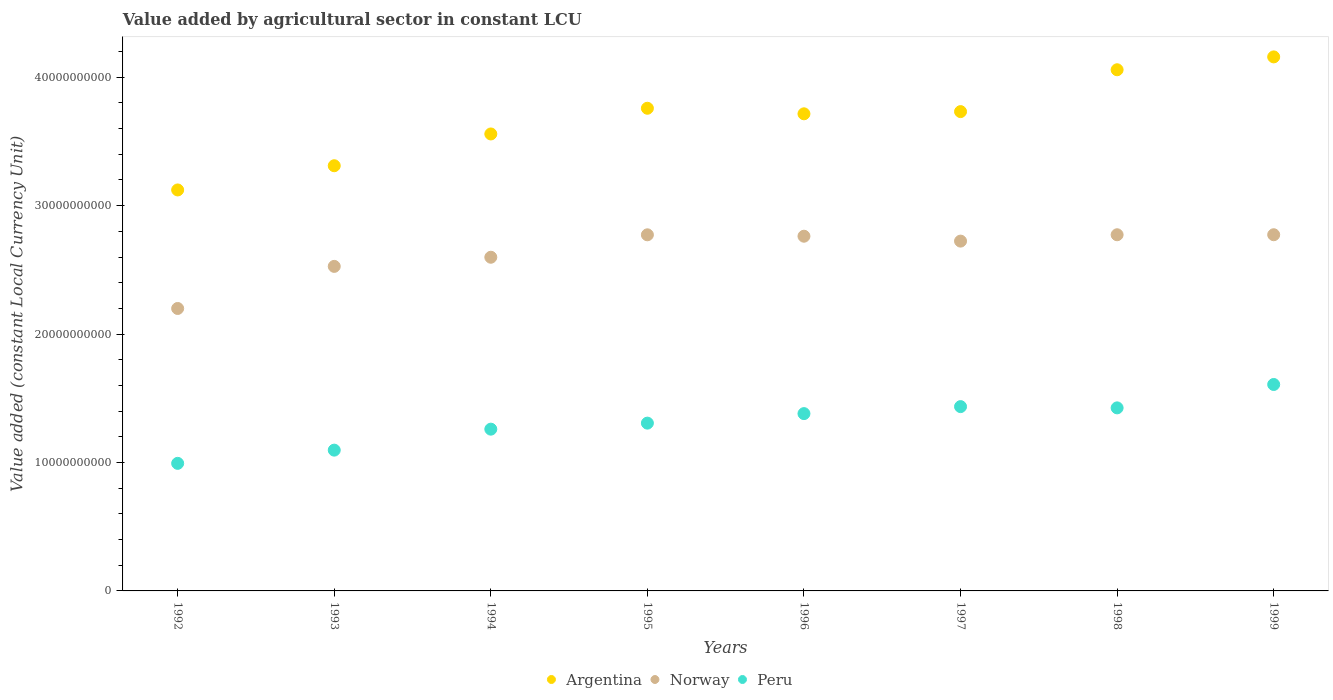How many different coloured dotlines are there?
Provide a short and direct response. 3. What is the value added by agricultural sector in Peru in 1999?
Offer a terse response. 1.61e+1. Across all years, what is the maximum value added by agricultural sector in Peru?
Your answer should be compact. 1.61e+1. Across all years, what is the minimum value added by agricultural sector in Norway?
Offer a terse response. 2.20e+1. What is the total value added by agricultural sector in Argentina in the graph?
Provide a short and direct response. 2.94e+11. What is the difference between the value added by agricultural sector in Peru in 1995 and that in 1999?
Offer a very short reply. -3.01e+09. What is the difference between the value added by agricultural sector in Argentina in 1995 and the value added by agricultural sector in Norway in 1996?
Provide a short and direct response. 9.96e+09. What is the average value added by agricultural sector in Norway per year?
Your answer should be very brief. 2.64e+1. In the year 1997, what is the difference between the value added by agricultural sector in Peru and value added by agricultural sector in Argentina?
Offer a very short reply. -2.30e+1. In how many years, is the value added by agricultural sector in Norway greater than 16000000000 LCU?
Give a very brief answer. 8. What is the ratio of the value added by agricultural sector in Norway in 1997 to that in 1999?
Provide a short and direct response. 0.98. Is the value added by agricultural sector in Norway in 1992 less than that in 1993?
Make the answer very short. Yes. What is the difference between the highest and the second highest value added by agricultural sector in Argentina?
Offer a very short reply. 1.00e+09. What is the difference between the highest and the lowest value added by agricultural sector in Norway?
Offer a very short reply. 5.74e+09. In how many years, is the value added by agricultural sector in Argentina greater than the average value added by agricultural sector in Argentina taken over all years?
Provide a succinct answer. 5. Does the value added by agricultural sector in Argentina monotonically increase over the years?
Offer a terse response. No. Is the value added by agricultural sector in Argentina strictly greater than the value added by agricultural sector in Norway over the years?
Give a very brief answer. Yes. How many years are there in the graph?
Provide a short and direct response. 8. Are the values on the major ticks of Y-axis written in scientific E-notation?
Offer a very short reply. No. Does the graph contain grids?
Ensure brevity in your answer.  No. How are the legend labels stacked?
Offer a very short reply. Horizontal. What is the title of the graph?
Your answer should be very brief. Value added by agricultural sector in constant LCU. What is the label or title of the Y-axis?
Ensure brevity in your answer.  Value added (constant Local Currency Unit). What is the Value added (constant Local Currency Unit) of Argentina in 1992?
Offer a terse response. 3.12e+1. What is the Value added (constant Local Currency Unit) in Norway in 1992?
Offer a very short reply. 2.20e+1. What is the Value added (constant Local Currency Unit) of Peru in 1992?
Offer a very short reply. 9.93e+09. What is the Value added (constant Local Currency Unit) of Argentina in 1993?
Your answer should be compact. 3.31e+1. What is the Value added (constant Local Currency Unit) of Norway in 1993?
Your answer should be very brief. 2.53e+1. What is the Value added (constant Local Currency Unit) in Peru in 1993?
Your response must be concise. 1.10e+1. What is the Value added (constant Local Currency Unit) of Argentina in 1994?
Your answer should be very brief. 3.56e+1. What is the Value added (constant Local Currency Unit) of Norway in 1994?
Keep it short and to the point. 2.60e+1. What is the Value added (constant Local Currency Unit) in Peru in 1994?
Make the answer very short. 1.26e+1. What is the Value added (constant Local Currency Unit) of Argentina in 1995?
Offer a terse response. 3.76e+1. What is the Value added (constant Local Currency Unit) in Norway in 1995?
Give a very brief answer. 2.77e+1. What is the Value added (constant Local Currency Unit) in Peru in 1995?
Your answer should be compact. 1.31e+1. What is the Value added (constant Local Currency Unit) in Argentina in 1996?
Give a very brief answer. 3.72e+1. What is the Value added (constant Local Currency Unit) of Norway in 1996?
Your answer should be very brief. 2.76e+1. What is the Value added (constant Local Currency Unit) in Peru in 1996?
Ensure brevity in your answer.  1.38e+1. What is the Value added (constant Local Currency Unit) of Argentina in 1997?
Ensure brevity in your answer.  3.73e+1. What is the Value added (constant Local Currency Unit) in Norway in 1997?
Make the answer very short. 2.72e+1. What is the Value added (constant Local Currency Unit) of Peru in 1997?
Make the answer very short. 1.44e+1. What is the Value added (constant Local Currency Unit) in Argentina in 1998?
Offer a very short reply. 4.06e+1. What is the Value added (constant Local Currency Unit) of Norway in 1998?
Ensure brevity in your answer.  2.77e+1. What is the Value added (constant Local Currency Unit) of Peru in 1998?
Your answer should be compact. 1.43e+1. What is the Value added (constant Local Currency Unit) in Argentina in 1999?
Keep it short and to the point. 4.16e+1. What is the Value added (constant Local Currency Unit) in Norway in 1999?
Offer a terse response. 2.77e+1. What is the Value added (constant Local Currency Unit) of Peru in 1999?
Ensure brevity in your answer.  1.61e+1. Across all years, what is the maximum Value added (constant Local Currency Unit) in Argentina?
Your response must be concise. 4.16e+1. Across all years, what is the maximum Value added (constant Local Currency Unit) in Norway?
Offer a terse response. 2.77e+1. Across all years, what is the maximum Value added (constant Local Currency Unit) of Peru?
Offer a very short reply. 1.61e+1. Across all years, what is the minimum Value added (constant Local Currency Unit) in Argentina?
Offer a very short reply. 3.12e+1. Across all years, what is the minimum Value added (constant Local Currency Unit) in Norway?
Your response must be concise. 2.20e+1. Across all years, what is the minimum Value added (constant Local Currency Unit) in Peru?
Give a very brief answer. 9.93e+09. What is the total Value added (constant Local Currency Unit) in Argentina in the graph?
Ensure brevity in your answer.  2.94e+11. What is the total Value added (constant Local Currency Unit) in Norway in the graph?
Offer a very short reply. 2.11e+11. What is the total Value added (constant Local Currency Unit) of Peru in the graph?
Offer a very short reply. 1.05e+11. What is the difference between the Value added (constant Local Currency Unit) of Argentina in 1992 and that in 1993?
Provide a short and direct response. -1.89e+09. What is the difference between the Value added (constant Local Currency Unit) in Norway in 1992 and that in 1993?
Your answer should be very brief. -3.28e+09. What is the difference between the Value added (constant Local Currency Unit) in Peru in 1992 and that in 1993?
Make the answer very short. -1.03e+09. What is the difference between the Value added (constant Local Currency Unit) of Argentina in 1992 and that in 1994?
Your response must be concise. -4.36e+09. What is the difference between the Value added (constant Local Currency Unit) of Norway in 1992 and that in 1994?
Provide a succinct answer. -3.99e+09. What is the difference between the Value added (constant Local Currency Unit) of Peru in 1992 and that in 1994?
Offer a terse response. -2.66e+09. What is the difference between the Value added (constant Local Currency Unit) in Argentina in 1992 and that in 1995?
Offer a terse response. -6.36e+09. What is the difference between the Value added (constant Local Currency Unit) in Norway in 1992 and that in 1995?
Provide a short and direct response. -5.74e+09. What is the difference between the Value added (constant Local Currency Unit) in Peru in 1992 and that in 1995?
Keep it short and to the point. -3.13e+09. What is the difference between the Value added (constant Local Currency Unit) in Argentina in 1992 and that in 1996?
Your answer should be very brief. -5.93e+09. What is the difference between the Value added (constant Local Currency Unit) of Norway in 1992 and that in 1996?
Offer a very short reply. -5.63e+09. What is the difference between the Value added (constant Local Currency Unit) in Peru in 1992 and that in 1996?
Provide a short and direct response. -3.87e+09. What is the difference between the Value added (constant Local Currency Unit) in Argentina in 1992 and that in 1997?
Provide a succinct answer. -6.10e+09. What is the difference between the Value added (constant Local Currency Unit) in Norway in 1992 and that in 1997?
Your answer should be very brief. -5.25e+09. What is the difference between the Value added (constant Local Currency Unit) of Peru in 1992 and that in 1997?
Offer a terse response. -4.42e+09. What is the difference between the Value added (constant Local Currency Unit) of Argentina in 1992 and that in 1998?
Provide a succinct answer. -9.36e+09. What is the difference between the Value added (constant Local Currency Unit) of Norway in 1992 and that in 1998?
Your answer should be compact. -5.74e+09. What is the difference between the Value added (constant Local Currency Unit) in Peru in 1992 and that in 1998?
Ensure brevity in your answer.  -4.32e+09. What is the difference between the Value added (constant Local Currency Unit) of Argentina in 1992 and that in 1999?
Your answer should be very brief. -1.04e+1. What is the difference between the Value added (constant Local Currency Unit) of Norway in 1992 and that in 1999?
Make the answer very short. -5.74e+09. What is the difference between the Value added (constant Local Currency Unit) of Peru in 1992 and that in 1999?
Provide a short and direct response. -6.14e+09. What is the difference between the Value added (constant Local Currency Unit) of Argentina in 1993 and that in 1994?
Your answer should be compact. -2.47e+09. What is the difference between the Value added (constant Local Currency Unit) in Norway in 1993 and that in 1994?
Ensure brevity in your answer.  -7.12e+08. What is the difference between the Value added (constant Local Currency Unit) of Peru in 1993 and that in 1994?
Your response must be concise. -1.63e+09. What is the difference between the Value added (constant Local Currency Unit) of Argentina in 1993 and that in 1995?
Your answer should be very brief. -4.48e+09. What is the difference between the Value added (constant Local Currency Unit) of Norway in 1993 and that in 1995?
Keep it short and to the point. -2.46e+09. What is the difference between the Value added (constant Local Currency Unit) in Peru in 1993 and that in 1995?
Offer a terse response. -2.10e+09. What is the difference between the Value added (constant Local Currency Unit) in Argentina in 1993 and that in 1996?
Offer a terse response. -4.04e+09. What is the difference between the Value added (constant Local Currency Unit) in Norway in 1993 and that in 1996?
Make the answer very short. -2.35e+09. What is the difference between the Value added (constant Local Currency Unit) in Peru in 1993 and that in 1996?
Provide a succinct answer. -2.84e+09. What is the difference between the Value added (constant Local Currency Unit) of Argentina in 1993 and that in 1997?
Offer a terse response. -4.21e+09. What is the difference between the Value added (constant Local Currency Unit) of Norway in 1993 and that in 1997?
Offer a terse response. -1.97e+09. What is the difference between the Value added (constant Local Currency Unit) of Peru in 1993 and that in 1997?
Ensure brevity in your answer.  -3.39e+09. What is the difference between the Value added (constant Local Currency Unit) of Argentina in 1993 and that in 1998?
Your answer should be very brief. -7.47e+09. What is the difference between the Value added (constant Local Currency Unit) in Norway in 1993 and that in 1998?
Offer a very short reply. -2.46e+09. What is the difference between the Value added (constant Local Currency Unit) in Peru in 1993 and that in 1998?
Offer a very short reply. -3.29e+09. What is the difference between the Value added (constant Local Currency Unit) in Argentina in 1993 and that in 1999?
Provide a succinct answer. -8.47e+09. What is the difference between the Value added (constant Local Currency Unit) in Norway in 1993 and that in 1999?
Provide a short and direct response. -2.46e+09. What is the difference between the Value added (constant Local Currency Unit) in Peru in 1993 and that in 1999?
Give a very brief answer. -5.11e+09. What is the difference between the Value added (constant Local Currency Unit) in Argentina in 1994 and that in 1995?
Offer a very short reply. -2.00e+09. What is the difference between the Value added (constant Local Currency Unit) of Norway in 1994 and that in 1995?
Provide a succinct answer. -1.75e+09. What is the difference between the Value added (constant Local Currency Unit) of Peru in 1994 and that in 1995?
Keep it short and to the point. -4.69e+08. What is the difference between the Value added (constant Local Currency Unit) of Argentina in 1994 and that in 1996?
Offer a terse response. -1.57e+09. What is the difference between the Value added (constant Local Currency Unit) in Norway in 1994 and that in 1996?
Your answer should be compact. -1.64e+09. What is the difference between the Value added (constant Local Currency Unit) in Peru in 1994 and that in 1996?
Offer a terse response. -1.21e+09. What is the difference between the Value added (constant Local Currency Unit) of Argentina in 1994 and that in 1997?
Your answer should be compact. -1.74e+09. What is the difference between the Value added (constant Local Currency Unit) in Norway in 1994 and that in 1997?
Your response must be concise. -1.26e+09. What is the difference between the Value added (constant Local Currency Unit) in Peru in 1994 and that in 1997?
Your answer should be compact. -1.76e+09. What is the difference between the Value added (constant Local Currency Unit) in Argentina in 1994 and that in 1998?
Offer a terse response. -5.00e+09. What is the difference between the Value added (constant Local Currency Unit) of Norway in 1994 and that in 1998?
Provide a succinct answer. -1.75e+09. What is the difference between the Value added (constant Local Currency Unit) in Peru in 1994 and that in 1998?
Ensure brevity in your answer.  -1.66e+09. What is the difference between the Value added (constant Local Currency Unit) of Argentina in 1994 and that in 1999?
Give a very brief answer. -6.00e+09. What is the difference between the Value added (constant Local Currency Unit) of Norway in 1994 and that in 1999?
Make the answer very short. -1.75e+09. What is the difference between the Value added (constant Local Currency Unit) of Peru in 1994 and that in 1999?
Your response must be concise. -3.48e+09. What is the difference between the Value added (constant Local Currency Unit) in Argentina in 1995 and that in 1996?
Offer a terse response. 4.32e+08. What is the difference between the Value added (constant Local Currency Unit) of Norway in 1995 and that in 1996?
Your answer should be very brief. 1.09e+08. What is the difference between the Value added (constant Local Currency Unit) in Peru in 1995 and that in 1996?
Provide a short and direct response. -7.41e+08. What is the difference between the Value added (constant Local Currency Unit) in Argentina in 1995 and that in 1997?
Your answer should be very brief. 2.61e+08. What is the difference between the Value added (constant Local Currency Unit) of Norway in 1995 and that in 1997?
Your answer should be very brief. 4.91e+08. What is the difference between the Value added (constant Local Currency Unit) in Peru in 1995 and that in 1997?
Provide a short and direct response. -1.29e+09. What is the difference between the Value added (constant Local Currency Unit) in Argentina in 1995 and that in 1998?
Provide a short and direct response. -3.00e+09. What is the difference between the Value added (constant Local Currency Unit) in Norway in 1995 and that in 1998?
Provide a succinct answer. -4.58e+06. What is the difference between the Value added (constant Local Currency Unit) in Peru in 1995 and that in 1998?
Offer a terse response. -1.19e+09. What is the difference between the Value added (constant Local Currency Unit) in Argentina in 1995 and that in 1999?
Make the answer very short. -4.00e+09. What is the difference between the Value added (constant Local Currency Unit) of Norway in 1995 and that in 1999?
Provide a succinct answer. -5.73e+06. What is the difference between the Value added (constant Local Currency Unit) of Peru in 1995 and that in 1999?
Your answer should be compact. -3.01e+09. What is the difference between the Value added (constant Local Currency Unit) in Argentina in 1996 and that in 1997?
Give a very brief answer. -1.71e+08. What is the difference between the Value added (constant Local Currency Unit) in Norway in 1996 and that in 1997?
Offer a very short reply. 3.82e+08. What is the difference between the Value added (constant Local Currency Unit) of Peru in 1996 and that in 1997?
Give a very brief answer. -5.45e+08. What is the difference between the Value added (constant Local Currency Unit) of Argentina in 1996 and that in 1998?
Provide a succinct answer. -3.43e+09. What is the difference between the Value added (constant Local Currency Unit) in Norway in 1996 and that in 1998?
Make the answer very short. -1.13e+08. What is the difference between the Value added (constant Local Currency Unit) in Peru in 1996 and that in 1998?
Your response must be concise. -4.47e+08. What is the difference between the Value added (constant Local Currency Unit) of Argentina in 1996 and that in 1999?
Give a very brief answer. -4.43e+09. What is the difference between the Value added (constant Local Currency Unit) of Norway in 1996 and that in 1999?
Offer a terse response. -1.15e+08. What is the difference between the Value added (constant Local Currency Unit) of Peru in 1996 and that in 1999?
Make the answer very short. -2.27e+09. What is the difference between the Value added (constant Local Currency Unit) of Argentina in 1997 and that in 1998?
Keep it short and to the point. -3.26e+09. What is the difference between the Value added (constant Local Currency Unit) in Norway in 1997 and that in 1998?
Your response must be concise. -4.95e+08. What is the difference between the Value added (constant Local Currency Unit) of Peru in 1997 and that in 1998?
Provide a succinct answer. 9.80e+07. What is the difference between the Value added (constant Local Currency Unit) in Argentina in 1997 and that in 1999?
Provide a succinct answer. -4.26e+09. What is the difference between the Value added (constant Local Currency Unit) in Norway in 1997 and that in 1999?
Ensure brevity in your answer.  -4.96e+08. What is the difference between the Value added (constant Local Currency Unit) of Peru in 1997 and that in 1999?
Ensure brevity in your answer.  -1.72e+09. What is the difference between the Value added (constant Local Currency Unit) of Argentina in 1998 and that in 1999?
Your answer should be very brief. -1.00e+09. What is the difference between the Value added (constant Local Currency Unit) of Norway in 1998 and that in 1999?
Keep it short and to the point. -1.15e+06. What is the difference between the Value added (constant Local Currency Unit) of Peru in 1998 and that in 1999?
Your answer should be very brief. -1.82e+09. What is the difference between the Value added (constant Local Currency Unit) of Argentina in 1992 and the Value added (constant Local Currency Unit) of Norway in 1993?
Give a very brief answer. 5.95e+09. What is the difference between the Value added (constant Local Currency Unit) of Argentina in 1992 and the Value added (constant Local Currency Unit) of Peru in 1993?
Offer a terse response. 2.03e+1. What is the difference between the Value added (constant Local Currency Unit) of Norway in 1992 and the Value added (constant Local Currency Unit) of Peru in 1993?
Offer a very short reply. 1.10e+1. What is the difference between the Value added (constant Local Currency Unit) in Argentina in 1992 and the Value added (constant Local Currency Unit) in Norway in 1994?
Keep it short and to the point. 5.24e+09. What is the difference between the Value added (constant Local Currency Unit) in Argentina in 1992 and the Value added (constant Local Currency Unit) in Peru in 1994?
Provide a succinct answer. 1.86e+1. What is the difference between the Value added (constant Local Currency Unit) of Norway in 1992 and the Value added (constant Local Currency Unit) of Peru in 1994?
Give a very brief answer. 9.40e+09. What is the difference between the Value added (constant Local Currency Unit) of Argentina in 1992 and the Value added (constant Local Currency Unit) of Norway in 1995?
Offer a terse response. 3.49e+09. What is the difference between the Value added (constant Local Currency Unit) of Argentina in 1992 and the Value added (constant Local Currency Unit) of Peru in 1995?
Your answer should be compact. 1.82e+1. What is the difference between the Value added (constant Local Currency Unit) of Norway in 1992 and the Value added (constant Local Currency Unit) of Peru in 1995?
Give a very brief answer. 8.93e+09. What is the difference between the Value added (constant Local Currency Unit) of Argentina in 1992 and the Value added (constant Local Currency Unit) of Norway in 1996?
Offer a terse response. 3.60e+09. What is the difference between the Value added (constant Local Currency Unit) in Argentina in 1992 and the Value added (constant Local Currency Unit) in Peru in 1996?
Ensure brevity in your answer.  1.74e+1. What is the difference between the Value added (constant Local Currency Unit) in Norway in 1992 and the Value added (constant Local Currency Unit) in Peru in 1996?
Give a very brief answer. 8.19e+09. What is the difference between the Value added (constant Local Currency Unit) of Argentina in 1992 and the Value added (constant Local Currency Unit) of Norway in 1997?
Your answer should be very brief. 3.98e+09. What is the difference between the Value added (constant Local Currency Unit) in Argentina in 1992 and the Value added (constant Local Currency Unit) in Peru in 1997?
Give a very brief answer. 1.69e+1. What is the difference between the Value added (constant Local Currency Unit) in Norway in 1992 and the Value added (constant Local Currency Unit) in Peru in 1997?
Your response must be concise. 7.64e+09. What is the difference between the Value added (constant Local Currency Unit) of Argentina in 1992 and the Value added (constant Local Currency Unit) of Norway in 1998?
Offer a very short reply. 3.49e+09. What is the difference between the Value added (constant Local Currency Unit) of Argentina in 1992 and the Value added (constant Local Currency Unit) of Peru in 1998?
Your answer should be compact. 1.70e+1. What is the difference between the Value added (constant Local Currency Unit) in Norway in 1992 and the Value added (constant Local Currency Unit) in Peru in 1998?
Provide a succinct answer. 7.74e+09. What is the difference between the Value added (constant Local Currency Unit) of Argentina in 1992 and the Value added (constant Local Currency Unit) of Norway in 1999?
Offer a very short reply. 3.49e+09. What is the difference between the Value added (constant Local Currency Unit) in Argentina in 1992 and the Value added (constant Local Currency Unit) in Peru in 1999?
Give a very brief answer. 1.51e+1. What is the difference between the Value added (constant Local Currency Unit) of Norway in 1992 and the Value added (constant Local Currency Unit) of Peru in 1999?
Keep it short and to the point. 5.92e+09. What is the difference between the Value added (constant Local Currency Unit) in Argentina in 1993 and the Value added (constant Local Currency Unit) in Norway in 1994?
Your answer should be very brief. 7.13e+09. What is the difference between the Value added (constant Local Currency Unit) of Argentina in 1993 and the Value added (constant Local Currency Unit) of Peru in 1994?
Provide a succinct answer. 2.05e+1. What is the difference between the Value added (constant Local Currency Unit) in Norway in 1993 and the Value added (constant Local Currency Unit) in Peru in 1994?
Your answer should be very brief. 1.27e+1. What is the difference between the Value added (constant Local Currency Unit) in Argentina in 1993 and the Value added (constant Local Currency Unit) in Norway in 1995?
Give a very brief answer. 5.38e+09. What is the difference between the Value added (constant Local Currency Unit) of Argentina in 1993 and the Value added (constant Local Currency Unit) of Peru in 1995?
Make the answer very short. 2.00e+1. What is the difference between the Value added (constant Local Currency Unit) of Norway in 1993 and the Value added (constant Local Currency Unit) of Peru in 1995?
Ensure brevity in your answer.  1.22e+1. What is the difference between the Value added (constant Local Currency Unit) of Argentina in 1993 and the Value added (constant Local Currency Unit) of Norway in 1996?
Make the answer very short. 5.49e+09. What is the difference between the Value added (constant Local Currency Unit) in Argentina in 1993 and the Value added (constant Local Currency Unit) in Peru in 1996?
Keep it short and to the point. 1.93e+1. What is the difference between the Value added (constant Local Currency Unit) of Norway in 1993 and the Value added (constant Local Currency Unit) of Peru in 1996?
Offer a terse response. 1.15e+1. What is the difference between the Value added (constant Local Currency Unit) in Argentina in 1993 and the Value added (constant Local Currency Unit) in Norway in 1997?
Offer a terse response. 5.87e+09. What is the difference between the Value added (constant Local Currency Unit) of Argentina in 1993 and the Value added (constant Local Currency Unit) of Peru in 1997?
Make the answer very short. 1.88e+1. What is the difference between the Value added (constant Local Currency Unit) of Norway in 1993 and the Value added (constant Local Currency Unit) of Peru in 1997?
Your response must be concise. 1.09e+1. What is the difference between the Value added (constant Local Currency Unit) in Argentina in 1993 and the Value added (constant Local Currency Unit) in Norway in 1998?
Provide a succinct answer. 5.37e+09. What is the difference between the Value added (constant Local Currency Unit) of Argentina in 1993 and the Value added (constant Local Currency Unit) of Peru in 1998?
Offer a terse response. 1.89e+1. What is the difference between the Value added (constant Local Currency Unit) in Norway in 1993 and the Value added (constant Local Currency Unit) in Peru in 1998?
Ensure brevity in your answer.  1.10e+1. What is the difference between the Value added (constant Local Currency Unit) of Argentina in 1993 and the Value added (constant Local Currency Unit) of Norway in 1999?
Offer a very short reply. 5.37e+09. What is the difference between the Value added (constant Local Currency Unit) in Argentina in 1993 and the Value added (constant Local Currency Unit) in Peru in 1999?
Ensure brevity in your answer.  1.70e+1. What is the difference between the Value added (constant Local Currency Unit) of Norway in 1993 and the Value added (constant Local Currency Unit) of Peru in 1999?
Give a very brief answer. 9.20e+09. What is the difference between the Value added (constant Local Currency Unit) of Argentina in 1994 and the Value added (constant Local Currency Unit) of Norway in 1995?
Offer a very short reply. 7.85e+09. What is the difference between the Value added (constant Local Currency Unit) of Argentina in 1994 and the Value added (constant Local Currency Unit) of Peru in 1995?
Your response must be concise. 2.25e+1. What is the difference between the Value added (constant Local Currency Unit) in Norway in 1994 and the Value added (constant Local Currency Unit) in Peru in 1995?
Give a very brief answer. 1.29e+1. What is the difference between the Value added (constant Local Currency Unit) in Argentina in 1994 and the Value added (constant Local Currency Unit) in Norway in 1996?
Make the answer very short. 7.96e+09. What is the difference between the Value added (constant Local Currency Unit) of Argentina in 1994 and the Value added (constant Local Currency Unit) of Peru in 1996?
Provide a succinct answer. 2.18e+1. What is the difference between the Value added (constant Local Currency Unit) in Norway in 1994 and the Value added (constant Local Currency Unit) in Peru in 1996?
Provide a short and direct response. 1.22e+1. What is the difference between the Value added (constant Local Currency Unit) in Argentina in 1994 and the Value added (constant Local Currency Unit) in Norway in 1997?
Your answer should be very brief. 8.34e+09. What is the difference between the Value added (constant Local Currency Unit) in Argentina in 1994 and the Value added (constant Local Currency Unit) in Peru in 1997?
Keep it short and to the point. 2.12e+1. What is the difference between the Value added (constant Local Currency Unit) of Norway in 1994 and the Value added (constant Local Currency Unit) of Peru in 1997?
Your answer should be compact. 1.16e+1. What is the difference between the Value added (constant Local Currency Unit) of Argentina in 1994 and the Value added (constant Local Currency Unit) of Norway in 1998?
Your answer should be very brief. 7.85e+09. What is the difference between the Value added (constant Local Currency Unit) of Argentina in 1994 and the Value added (constant Local Currency Unit) of Peru in 1998?
Ensure brevity in your answer.  2.13e+1. What is the difference between the Value added (constant Local Currency Unit) of Norway in 1994 and the Value added (constant Local Currency Unit) of Peru in 1998?
Make the answer very short. 1.17e+1. What is the difference between the Value added (constant Local Currency Unit) in Argentina in 1994 and the Value added (constant Local Currency Unit) in Norway in 1999?
Your answer should be compact. 7.85e+09. What is the difference between the Value added (constant Local Currency Unit) of Argentina in 1994 and the Value added (constant Local Currency Unit) of Peru in 1999?
Provide a short and direct response. 1.95e+1. What is the difference between the Value added (constant Local Currency Unit) in Norway in 1994 and the Value added (constant Local Currency Unit) in Peru in 1999?
Your answer should be compact. 9.91e+09. What is the difference between the Value added (constant Local Currency Unit) of Argentina in 1995 and the Value added (constant Local Currency Unit) of Norway in 1996?
Your answer should be very brief. 9.96e+09. What is the difference between the Value added (constant Local Currency Unit) of Argentina in 1995 and the Value added (constant Local Currency Unit) of Peru in 1996?
Your answer should be very brief. 2.38e+1. What is the difference between the Value added (constant Local Currency Unit) in Norway in 1995 and the Value added (constant Local Currency Unit) in Peru in 1996?
Provide a short and direct response. 1.39e+1. What is the difference between the Value added (constant Local Currency Unit) of Argentina in 1995 and the Value added (constant Local Currency Unit) of Norway in 1997?
Your answer should be very brief. 1.03e+1. What is the difference between the Value added (constant Local Currency Unit) in Argentina in 1995 and the Value added (constant Local Currency Unit) in Peru in 1997?
Your answer should be very brief. 2.32e+1. What is the difference between the Value added (constant Local Currency Unit) of Norway in 1995 and the Value added (constant Local Currency Unit) of Peru in 1997?
Offer a very short reply. 1.34e+1. What is the difference between the Value added (constant Local Currency Unit) of Argentina in 1995 and the Value added (constant Local Currency Unit) of Norway in 1998?
Your response must be concise. 9.85e+09. What is the difference between the Value added (constant Local Currency Unit) of Argentina in 1995 and the Value added (constant Local Currency Unit) of Peru in 1998?
Your answer should be compact. 2.33e+1. What is the difference between the Value added (constant Local Currency Unit) in Norway in 1995 and the Value added (constant Local Currency Unit) in Peru in 1998?
Ensure brevity in your answer.  1.35e+1. What is the difference between the Value added (constant Local Currency Unit) of Argentina in 1995 and the Value added (constant Local Currency Unit) of Norway in 1999?
Your answer should be compact. 9.85e+09. What is the difference between the Value added (constant Local Currency Unit) in Argentina in 1995 and the Value added (constant Local Currency Unit) in Peru in 1999?
Provide a short and direct response. 2.15e+1. What is the difference between the Value added (constant Local Currency Unit) of Norway in 1995 and the Value added (constant Local Currency Unit) of Peru in 1999?
Provide a short and direct response. 1.17e+1. What is the difference between the Value added (constant Local Currency Unit) of Argentina in 1996 and the Value added (constant Local Currency Unit) of Norway in 1997?
Make the answer very short. 9.91e+09. What is the difference between the Value added (constant Local Currency Unit) of Argentina in 1996 and the Value added (constant Local Currency Unit) of Peru in 1997?
Your answer should be compact. 2.28e+1. What is the difference between the Value added (constant Local Currency Unit) of Norway in 1996 and the Value added (constant Local Currency Unit) of Peru in 1997?
Provide a succinct answer. 1.33e+1. What is the difference between the Value added (constant Local Currency Unit) in Argentina in 1996 and the Value added (constant Local Currency Unit) in Norway in 1998?
Your answer should be very brief. 9.42e+09. What is the difference between the Value added (constant Local Currency Unit) of Argentina in 1996 and the Value added (constant Local Currency Unit) of Peru in 1998?
Keep it short and to the point. 2.29e+1. What is the difference between the Value added (constant Local Currency Unit) of Norway in 1996 and the Value added (constant Local Currency Unit) of Peru in 1998?
Your answer should be compact. 1.34e+1. What is the difference between the Value added (constant Local Currency Unit) of Argentina in 1996 and the Value added (constant Local Currency Unit) of Norway in 1999?
Offer a terse response. 9.42e+09. What is the difference between the Value added (constant Local Currency Unit) in Argentina in 1996 and the Value added (constant Local Currency Unit) in Peru in 1999?
Your response must be concise. 2.11e+1. What is the difference between the Value added (constant Local Currency Unit) of Norway in 1996 and the Value added (constant Local Currency Unit) of Peru in 1999?
Offer a terse response. 1.15e+1. What is the difference between the Value added (constant Local Currency Unit) in Argentina in 1997 and the Value added (constant Local Currency Unit) in Norway in 1998?
Your answer should be very brief. 9.59e+09. What is the difference between the Value added (constant Local Currency Unit) of Argentina in 1997 and the Value added (constant Local Currency Unit) of Peru in 1998?
Provide a short and direct response. 2.31e+1. What is the difference between the Value added (constant Local Currency Unit) of Norway in 1997 and the Value added (constant Local Currency Unit) of Peru in 1998?
Provide a short and direct response. 1.30e+1. What is the difference between the Value added (constant Local Currency Unit) in Argentina in 1997 and the Value added (constant Local Currency Unit) in Norway in 1999?
Your answer should be very brief. 9.59e+09. What is the difference between the Value added (constant Local Currency Unit) of Argentina in 1997 and the Value added (constant Local Currency Unit) of Peru in 1999?
Keep it short and to the point. 2.12e+1. What is the difference between the Value added (constant Local Currency Unit) of Norway in 1997 and the Value added (constant Local Currency Unit) of Peru in 1999?
Offer a very short reply. 1.12e+1. What is the difference between the Value added (constant Local Currency Unit) in Argentina in 1998 and the Value added (constant Local Currency Unit) in Norway in 1999?
Your response must be concise. 1.28e+1. What is the difference between the Value added (constant Local Currency Unit) in Argentina in 1998 and the Value added (constant Local Currency Unit) in Peru in 1999?
Ensure brevity in your answer.  2.45e+1. What is the difference between the Value added (constant Local Currency Unit) of Norway in 1998 and the Value added (constant Local Currency Unit) of Peru in 1999?
Ensure brevity in your answer.  1.17e+1. What is the average Value added (constant Local Currency Unit) of Argentina per year?
Provide a succinct answer. 3.68e+1. What is the average Value added (constant Local Currency Unit) in Norway per year?
Ensure brevity in your answer.  2.64e+1. What is the average Value added (constant Local Currency Unit) in Peru per year?
Your response must be concise. 1.31e+1. In the year 1992, what is the difference between the Value added (constant Local Currency Unit) in Argentina and Value added (constant Local Currency Unit) in Norway?
Your response must be concise. 9.23e+09. In the year 1992, what is the difference between the Value added (constant Local Currency Unit) of Argentina and Value added (constant Local Currency Unit) of Peru?
Your answer should be very brief. 2.13e+1. In the year 1992, what is the difference between the Value added (constant Local Currency Unit) of Norway and Value added (constant Local Currency Unit) of Peru?
Offer a very short reply. 1.21e+1. In the year 1993, what is the difference between the Value added (constant Local Currency Unit) of Argentina and Value added (constant Local Currency Unit) of Norway?
Your response must be concise. 7.84e+09. In the year 1993, what is the difference between the Value added (constant Local Currency Unit) of Argentina and Value added (constant Local Currency Unit) of Peru?
Give a very brief answer. 2.21e+1. In the year 1993, what is the difference between the Value added (constant Local Currency Unit) of Norway and Value added (constant Local Currency Unit) of Peru?
Your response must be concise. 1.43e+1. In the year 1994, what is the difference between the Value added (constant Local Currency Unit) of Argentina and Value added (constant Local Currency Unit) of Norway?
Ensure brevity in your answer.  9.60e+09. In the year 1994, what is the difference between the Value added (constant Local Currency Unit) in Argentina and Value added (constant Local Currency Unit) in Peru?
Give a very brief answer. 2.30e+1. In the year 1994, what is the difference between the Value added (constant Local Currency Unit) of Norway and Value added (constant Local Currency Unit) of Peru?
Provide a succinct answer. 1.34e+1. In the year 1995, what is the difference between the Value added (constant Local Currency Unit) in Argentina and Value added (constant Local Currency Unit) in Norway?
Your answer should be very brief. 9.85e+09. In the year 1995, what is the difference between the Value added (constant Local Currency Unit) in Argentina and Value added (constant Local Currency Unit) in Peru?
Provide a short and direct response. 2.45e+1. In the year 1995, what is the difference between the Value added (constant Local Currency Unit) of Norway and Value added (constant Local Currency Unit) of Peru?
Make the answer very short. 1.47e+1. In the year 1996, what is the difference between the Value added (constant Local Currency Unit) in Argentina and Value added (constant Local Currency Unit) in Norway?
Give a very brief answer. 9.53e+09. In the year 1996, what is the difference between the Value added (constant Local Currency Unit) of Argentina and Value added (constant Local Currency Unit) of Peru?
Give a very brief answer. 2.33e+1. In the year 1996, what is the difference between the Value added (constant Local Currency Unit) in Norway and Value added (constant Local Currency Unit) in Peru?
Provide a short and direct response. 1.38e+1. In the year 1997, what is the difference between the Value added (constant Local Currency Unit) in Argentina and Value added (constant Local Currency Unit) in Norway?
Your response must be concise. 1.01e+1. In the year 1997, what is the difference between the Value added (constant Local Currency Unit) in Argentina and Value added (constant Local Currency Unit) in Peru?
Ensure brevity in your answer.  2.30e+1. In the year 1997, what is the difference between the Value added (constant Local Currency Unit) in Norway and Value added (constant Local Currency Unit) in Peru?
Make the answer very short. 1.29e+1. In the year 1998, what is the difference between the Value added (constant Local Currency Unit) of Argentina and Value added (constant Local Currency Unit) of Norway?
Your response must be concise. 1.28e+1. In the year 1998, what is the difference between the Value added (constant Local Currency Unit) in Argentina and Value added (constant Local Currency Unit) in Peru?
Provide a succinct answer. 2.63e+1. In the year 1998, what is the difference between the Value added (constant Local Currency Unit) of Norway and Value added (constant Local Currency Unit) of Peru?
Make the answer very short. 1.35e+1. In the year 1999, what is the difference between the Value added (constant Local Currency Unit) of Argentina and Value added (constant Local Currency Unit) of Norway?
Keep it short and to the point. 1.38e+1. In the year 1999, what is the difference between the Value added (constant Local Currency Unit) in Argentina and Value added (constant Local Currency Unit) in Peru?
Offer a very short reply. 2.55e+1. In the year 1999, what is the difference between the Value added (constant Local Currency Unit) in Norway and Value added (constant Local Currency Unit) in Peru?
Your answer should be very brief. 1.17e+1. What is the ratio of the Value added (constant Local Currency Unit) in Argentina in 1992 to that in 1993?
Provide a short and direct response. 0.94. What is the ratio of the Value added (constant Local Currency Unit) in Norway in 1992 to that in 1993?
Make the answer very short. 0.87. What is the ratio of the Value added (constant Local Currency Unit) in Peru in 1992 to that in 1993?
Your answer should be compact. 0.91. What is the ratio of the Value added (constant Local Currency Unit) in Argentina in 1992 to that in 1994?
Offer a very short reply. 0.88. What is the ratio of the Value added (constant Local Currency Unit) in Norway in 1992 to that in 1994?
Offer a terse response. 0.85. What is the ratio of the Value added (constant Local Currency Unit) of Peru in 1992 to that in 1994?
Provide a short and direct response. 0.79. What is the ratio of the Value added (constant Local Currency Unit) in Argentina in 1992 to that in 1995?
Keep it short and to the point. 0.83. What is the ratio of the Value added (constant Local Currency Unit) of Norway in 1992 to that in 1995?
Ensure brevity in your answer.  0.79. What is the ratio of the Value added (constant Local Currency Unit) of Peru in 1992 to that in 1995?
Keep it short and to the point. 0.76. What is the ratio of the Value added (constant Local Currency Unit) of Argentina in 1992 to that in 1996?
Your answer should be compact. 0.84. What is the ratio of the Value added (constant Local Currency Unit) in Norway in 1992 to that in 1996?
Offer a very short reply. 0.8. What is the ratio of the Value added (constant Local Currency Unit) in Peru in 1992 to that in 1996?
Your answer should be very brief. 0.72. What is the ratio of the Value added (constant Local Currency Unit) of Argentina in 1992 to that in 1997?
Provide a succinct answer. 0.84. What is the ratio of the Value added (constant Local Currency Unit) of Norway in 1992 to that in 1997?
Offer a terse response. 0.81. What is the ratio of the Value added (constant Local Currency Unit) in Peru in 1992 to that in 1997?
Your answer should be very brief. 0.69. What is the ratio of the Value added (constant Local Currency Unit) of Argentina in 1992 to that in 1998?
Provide a short and direct response. 0.77. What is the ratio of the Value added (constant Local Currency Unit) in Norway in 1992 to that in 1998?
Your answer should be very brief. 0.79. What is the ratio of the Value added (constant Local Currency Unit) of Peru in 1992 to that in 1998?
Give a very brief answer. 0.7. What is the ratio of the Value added (constant Local Currency Unit) in Argentina in 1992 to that in 1999?
Your answer should be compact. 0.75. What is the ratio of the Value added (constant Local Currency Unit) in Norway in 1992 to that in 1999?
Give a very brief answer. 0.79. What is the ratio of the Value added (constant Local Currency Unit) of Peru in 1992 to that in 1999?
Ensure brevity in your answer.  0.62. What is the ratio of the Value added (constant Local Currency Unit) of Argentina in 1993 to that in 1994?
Your response must be concise. 0.93. What is the ratio of the Value added (constant Local Currency Unit) of Norway in 1993 to that in 1994?
Make the answer very short. 0.97. What is the ratio of the Value added (constant Local Currency Unit) in Peru in 1993 to that in 1994?
Offer a very short reply. 0.87. What is the ratio of the Value added (constant Local Currency Unit) in Argentina in 1993 to that in 1995?
Your response must be concise. 0.88. What is the ratio of the Value added (constant Local Currency Unit) in Norway in 1993 to that in 1995?
Your answer should be compact. 0.91. What is the ratio of the Value added (constant Local Currency Unit) of Peru in 1993 to that in 1995?
Provide a succinct answer. 0.84. What is the ratio of the Value added (constant Local Currency Unit) in Argentina in 1993 to that in 1996?
Give a very brief answer. 0.89. What is the ratio of the Value added (constant Local Currency Unit) of Norway in 1993 to that in 1996?
Provide a succinct answer. 0.91. What is the ratio of the Value added (constant Local Currency Unit) of Peru in 1993 to that in 1996?
Give a very brief answer. 0.79. What is the ratio of the Value added (constant Local Currency Unit) of Argentina in 1993 to that in 1997?
Make the answer very short. 0.89. What is the ratio of the Value added (constant Local Currency Unit) in Norway in 1993 to that in 1997?
Offer a very short reply. 0.93. What is the ratio of the Value added (constant Local Currency Unit) in Peru in 1993 to that in 1997?
Your answer should be compact. 0.76. What is the ratio of the Value added (constant Local Currency Unit) in Argentina in 1993 to that in 1998?
Your answer should be compact. 0.82. What is the ratio of the Value added (constant Local Currency Unit) of Norway in 1993 to that in 1998?
Provide a short and direct response. 0.91. What is the ratio of the Value added (constant Local Currency Unit) in Peru in 1993 to that in 1998?
Offer a very short reply. 0.77. What is the ratio of the Value added (constant Local Currency Unit) in Argentina in 1993 to that in 1999?
Offer a terse response. 0.8. What is the ratio of the Value added (constant Local Currency Unit) in Norway in 1993 to that in 1999?
Offer a terse response. 0.91. What is the ratio of the Value added (constant Local Currency Unit) of Peru in 1993 to that in 1999?
Ensure brevity in your answer.  0.68. What is the ratio of the Value added (constant Local Currency Unit) in Argentina in 1994 to that in 1995?
Your response must be concise. 0.95. What is the ratio of the Value added (constant Local Currency Unit) of Norway in 1994 to that in 1995?
Ensure brevity in your answer.  0.94. What is the ratio of the Value added (constant Local Currency Unit) in Peru in 1994 to that in 1995?
Offer a very short reply. 0.96. What is the ratio of the Value added (constant Local Currency Unit) of Argentina in 1994 to that in 1996?
Give a very brief answer. 0.96. What is the ratio of the Value added (constant Local Currency Unit) in Norway in 1994 to that in 1996?
Provide a succinct answer. 0.94. What is the ratio of the Value added (constant Local Currency Unit) of Peru in 1994 to that in 1996?
Your answer should be compact. 0.91. What is the ratio of the Value added (constant Local Currency Unit) in Argentina in 1994 to that in 1997?
Your answer should be compact. 0.95. What is the ratio of the Value added (constant Local Currency Unit) of Norway in 1994 to that in 1997?
Keep it short and to the point. 0.95. What is the ratio of the Value added (constant Local Currency Unit) of Peru in 1994 to that in 1997?
Make the answer very short. 0.88. What is the ratio of the Value added (constant Local Currency Unit) of Argentina in 1994 to that in 1998?
Keep it short and to the point. 0.88. What is the ratio of the Value added (constant Local Currency Unit) of Norway in 1994 to that in 1998?
Make the answer very short. 0.94. What is the ratio of the Value added (constant Local Currency Unit) in Peru in 1994 to that in 1998?
Offer a terse response. 0.88. What is the ratio of the Value added (constant Local Currency Unit) of Argentina in 1994 to that in 1999?
Offer a terse response. 0.86. What is the ratio of the Value added (constant Local Currency Unit) of Norway in 1994 to that in 1999?
Offer a very short reply. 0.94. What is the ratio of the Value added (constant Local Currency Unit) in Peru in 1994 to that in 1999?
Your answer should be very brief. 0.78. What is the ratio of the Value added (constant Local Currency Unit) in Argentina in 1995 to that in 1996?
Offer a terse response. 1.01. What is the ratio of the Value added (constant Local Currency Unit) of Peru in 1995 to that in 1996?
Your answer should be very brief. 0.95. What is the ratio of the Value added (constant Local Currency Unit) of Peru in 1995 to that in 1997?
Offer a terse response. 0.91. What is the ratio of the Value added (constant Local Currency Unit) in Argentina in 1995 to that in 1998?
Offer a terse response. 0.93. What is the ratio of the Value added (constant Local Currency Unit) of Norway in 1995 to that in 1998?
Your response must be concise. 1. What is the ratio of the Value added (constant Local Currency Unit) of Peru in 1995 to that in 1998?
Your response must be concise. 0.92. What is the ratio of the Value added (constant Local Currency Unit) of Argentina in 1995 to that in 1999?
Your answer should be compact. 0.9. What is the ratio of the Value added (constant Local Currency Unit) of Norway in 1995 to that in 1999?
Make the answer very short. 1. What is the ratio of the Value added (constant Local Currency Unit) in Peru in 1995 to that in 1999?
Your response must be concise. 0.81. What is the ratio of the Value added (constant Local Currency Unit) of Argentina in 1996 to that in 1997?
Your answer should be compact. 1. What is the ratio of the Value added (constant Local Currency Unit) in Norway in 1996 to that in 1997?
Offer a terse response. 1.01. What is the ratio of the Value added (constant Local Currency Unit) in Peru in 1996 to that in 1997?
Provide a short and direct response. 0.96. What is the ratio of the Value added (constant Local Currency Unit) in Argentina in 1996 to that in 1998?
Your response must be concise. 0.92. What is the ratio of the Value added (constant Local Currency Unit) of Norway in 1996 to that in 1998?
Provide a short and direct response. 1. What is the ratio of the Value added (constant Local Currency Unit) in Peru in 1996 to that in 1998?
Make the answer very short. 0.97. What is the ratio of the Value added (constant Local Currency Unit) of Argentina in 1996 to that in 1999?
Keep it short and to the point. 0.89. What is the ratio of the Value added (constant Local Currency Unit) of Peru in 1996 to that in 1999?
Your response must be concise. 0.86. What is the ratio of the Value added (constant Local Currency Unit) in Argentina in 1997 to that in 1998?
Your response must be concise. 0.92. What is the ratio of the Value added (constant Local Currency Unit) in Norway in 1997 to that in 1998?
Ensure brevity in your answer.  0.98. What is the ratio of the Value added (constant Local Currency Unit) in Argentina in 1997 to that in 1999?
Make the answer very short. 0.9. What is the ratio of the Value added (constant Local Currency Unit) in Norway in 1997 to that in 1999?
Your answer should be compact. 0.98. What is the ratio of the Value added (constant Local Currency Unit) in Peru in 1997 to that in 1999?
Ensure brevity in your answer.  0.89. What is the ratio of the Value added (constant Local Currency Unit) in Argentina in 1998 to that in 1999?
Your answer should be compact. 0.98. What is the ratio of the Value added (constant Local Currency Unit) in Norway in 1998 to that in 1999?
Make the answer very short. 1. What is the ratio of the Value added (constant Local Currency Unit) of Peru in 1998 to that in 1999?
Make the answer very short. 0.89. What is the difference between the highest and the second highest Value added (constant Local Currency Unit) in Argentina?
Provide a short and direct response. 1.00e+09. What is the difference between the highest and the second highest Value added (constant Local Currency Unit) of Norway?
Your answer should be very brief. 1.15e+06. What is the difference between the highest and the second highest Value added (constant Local Currency Unit) in Peru?
Give a very brief answer. 1.72e+09. What is the difference between the highest and the lowest Value added (constant Local Currency Unit) of Argentina?
Your answer should be compact. 1.04e+1. What is the difference between the highest and the lowest Value added (constant Local Currency Unit) of Norway?
Your response must be concise. 5.74e+09. What is the difference between the highest and the lowest Value added (constant Local Currency Unit) in Peru?
Ensure brevity in your answer.  6.14e+09. 